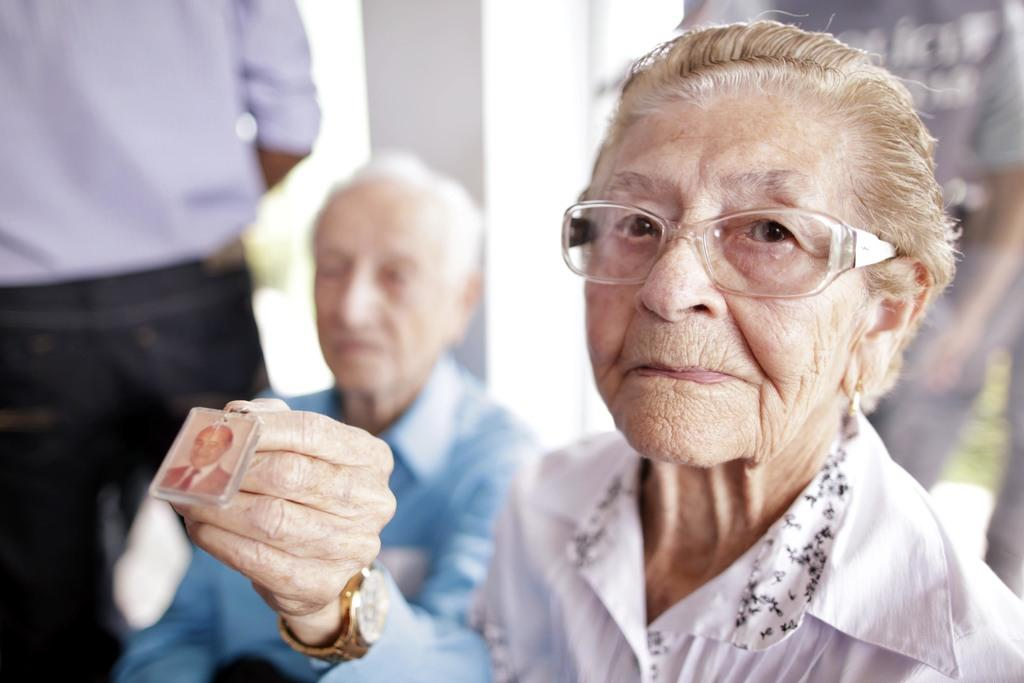How many people are present in the image? There are two people in the image, a man and a woman. What is the man holding in the image? The man is holding an object. Can you describe the man's accessories in the image? The man is wearing a watch. Can you describe the woman's accessories in the image? The woman is wearing glasses. What can be seen in the background of the image? There are people in the background of the image. What type of feather can be seen in the man's hair in the image? There is no feather present in the man's hair in the image. What type of toothbrush is the woman using in the image? There is no toothbrush present in the image. 